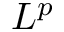Convert formula to latex. <formula><loc_0><loc_0><loc_500><loc_500>L ^ { p }</formula> 